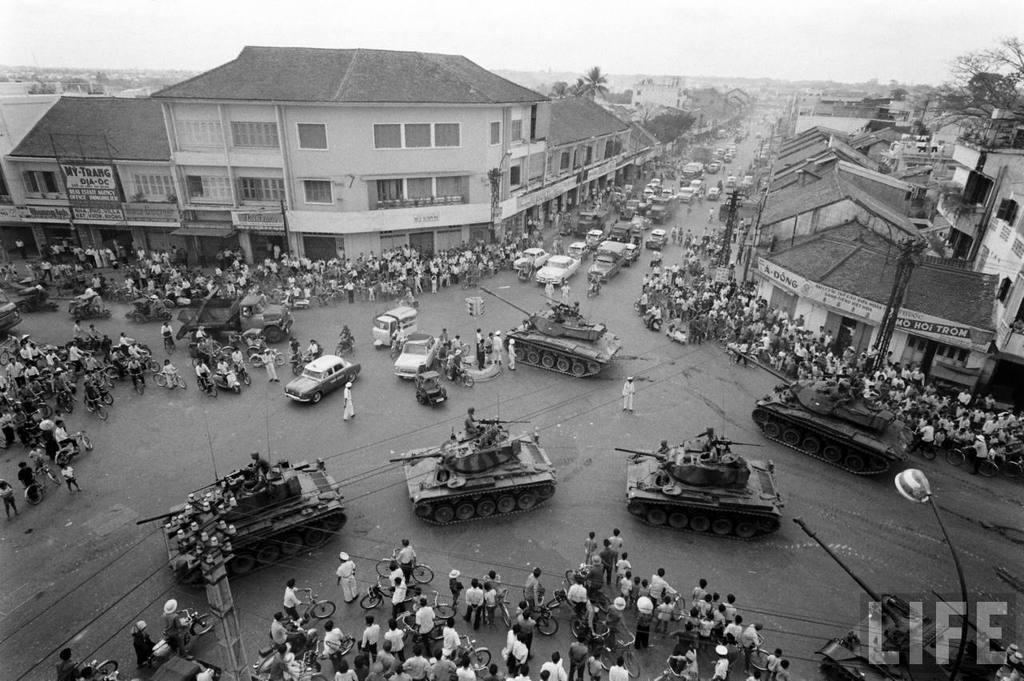Describe this image in one or two sentences. In this picture I can see many thanks on the road. Beside that I can see many cars and bikes. Beside the road I can see many people were standing. In the background I can see the buildings, trees, plants, grass, poles, street lights and other objects. In the top right I can see the sky and clouds. In the bottom right corner there is a watermark. 